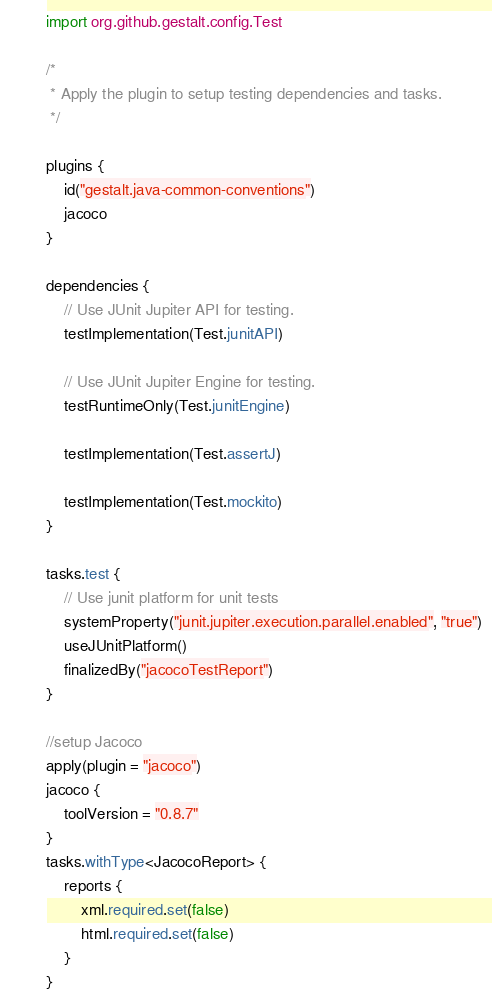<code> <loc_0><loc_0><loc_500><loc_500><_Kotlin_>import org.github.gestalt.config.Test

/*
 * Apply the plugin to setup testing dependencies and tasks.
 */

plugins {
    id("gestalt.java-common-conventions")
    jacoco
}

dependencies {
    // Use JUnit Jupiter API for testing.
    testImplementation(Test.junitAPI)

    // Use JUnit Jupiter Engine for testing.
    testRuntimeOnly(Test.junitEngine)

    testImplementation(Test.assertJ)

    testImplementation(Test.mockito)
}

tasks.test {
    // Use junit platform for unit tests
    systemProperty("junit.jupiter.execution.parallel.enabled", "true")
    useJUnitPlatform()
    finalizedBy("jacocoTestReport")
}

//setup Jacoco
apply(plugin = "jacoco")
jacoco {
    toolVersion = "0.8.7"
}
tasks.withType<JacocoReport> {
    reports {
        xml.required.set(false)
        html.required.set(false)
    }
}
</code> 